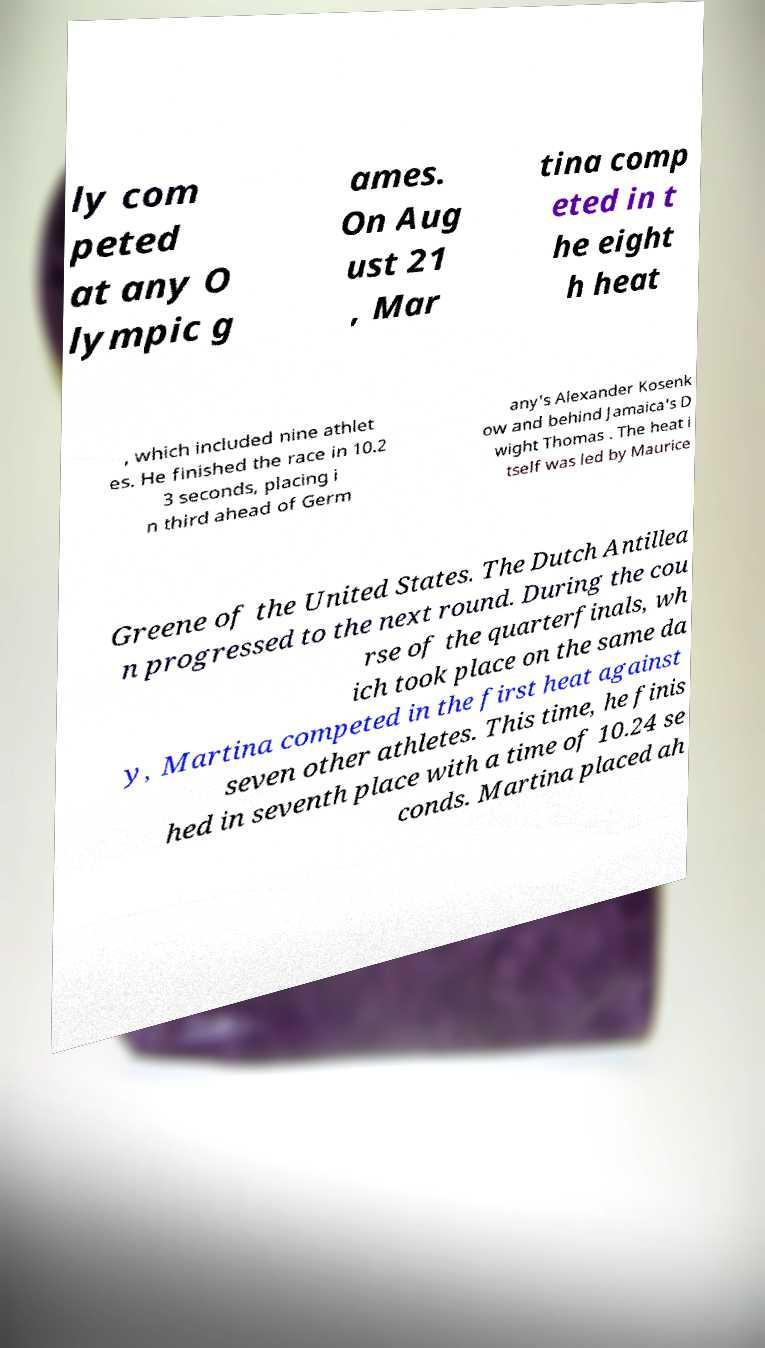Could you assist in decoding the text presented in this image and type it out clearly? ly com peted at any O lympic g ames. On Aug ust 21 , Mar tina comp eted in t he eight h heat , which included nine athlet es. He finished the race in 10.2 3 seconds, placing i n third ahead of Germ any's Alexander Kosenk ow and behind Jamaica's D wight Thomas . The heat i tself was led by Maurice Greene of the United States. The Dutch Antillea n progressed to the next round. During the cou rse of the quarterfinals, wh ich took place on the same da y, Martina competed in the first heat against seven other athletes. This time, he finis hed in seventh place with a time of 10.24 se conds. Martina placed ah 